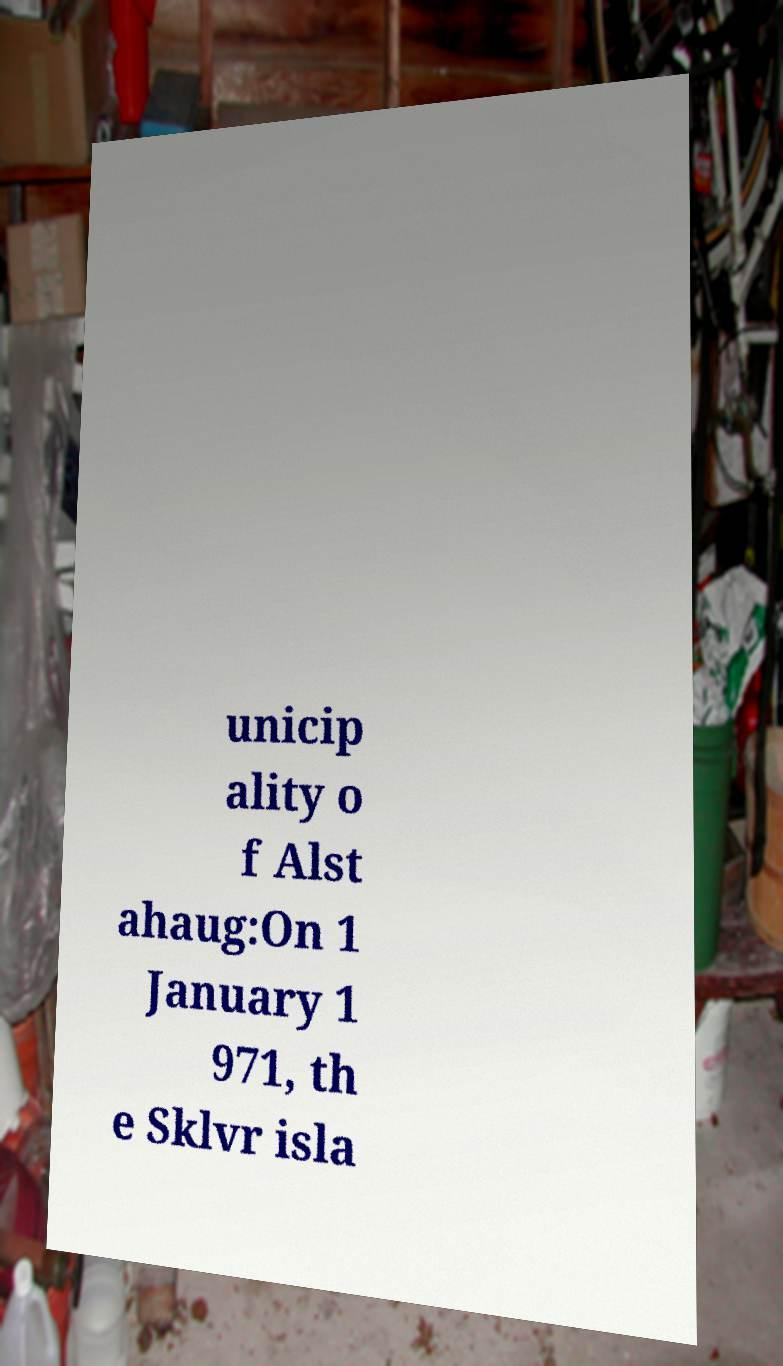Could you extract and type out the text from this image? unicip ality o f Alst ahaug:On 1 January 1 971, th e Sklvr isla 